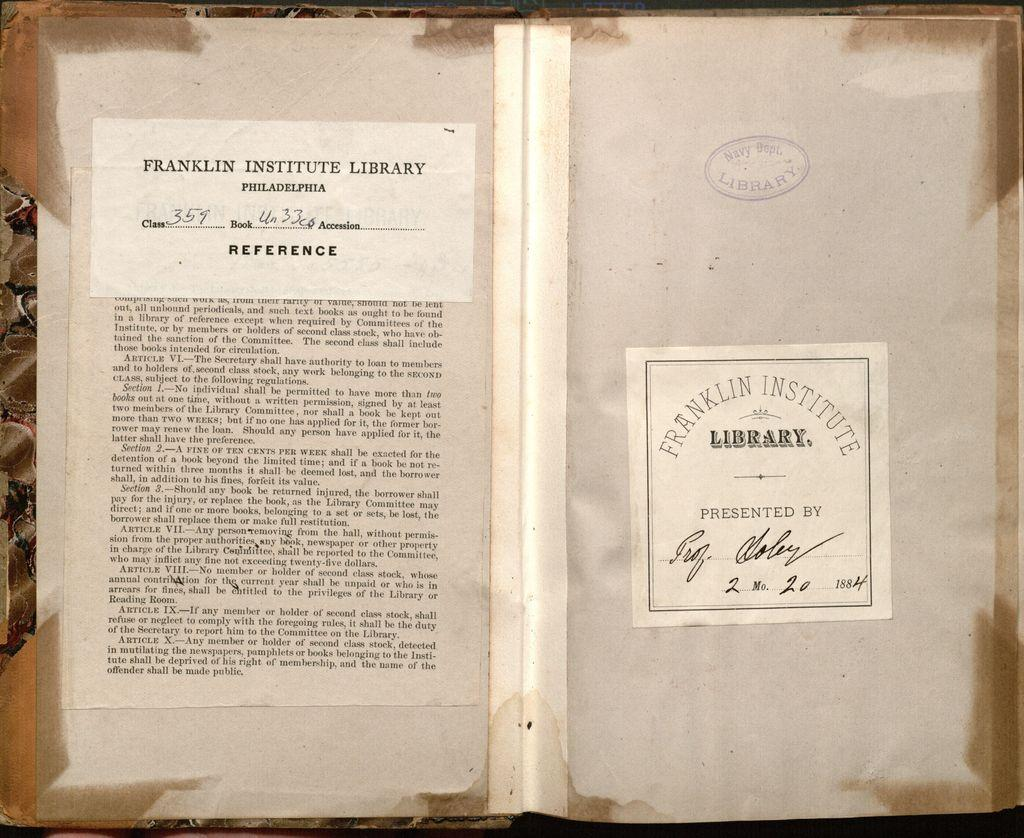<image>
Provide a brief description of the given image. Pieces of paper from Franklin's Institute Library from 1884. 